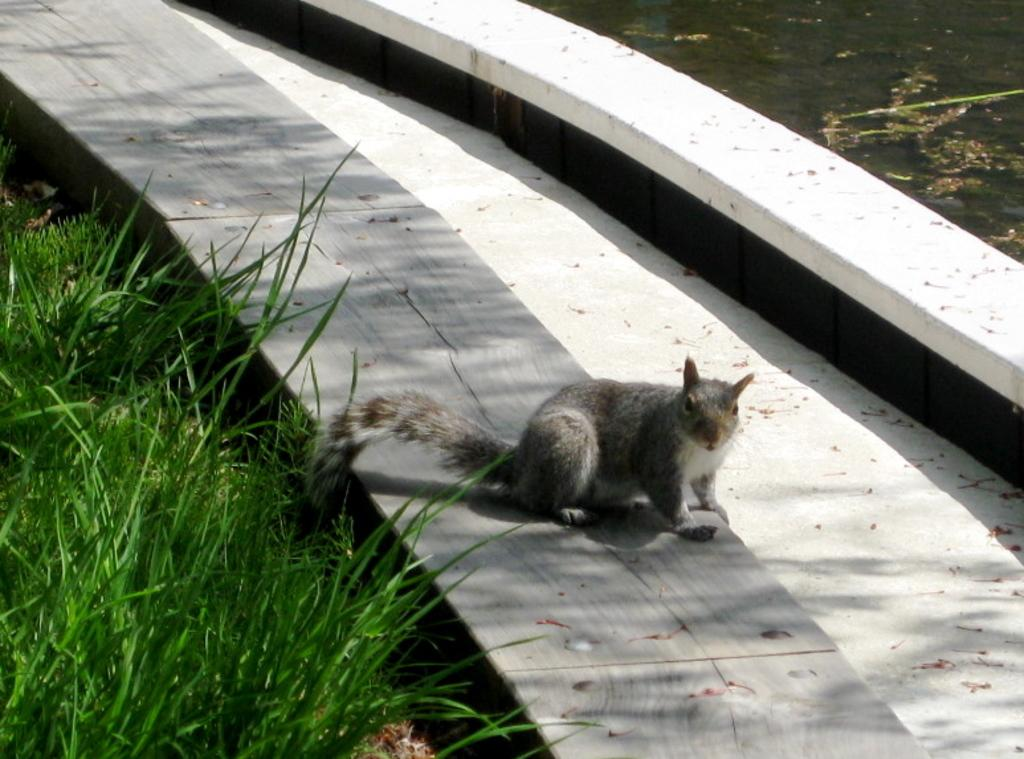What animal can be seen in the image? There is a squirrel on a stone surface in the image. What type of natural feature is visible in the right top of the image? There is a water body in the right top of the image. What type of vegetation is present in the left bottom of the image? There is grass in the left bottom of the image. What type of fuel is the squirrel using to move around in the image? The squirrel does not use fuel to move around in the image; it is a living creature that moves using its own energy. 